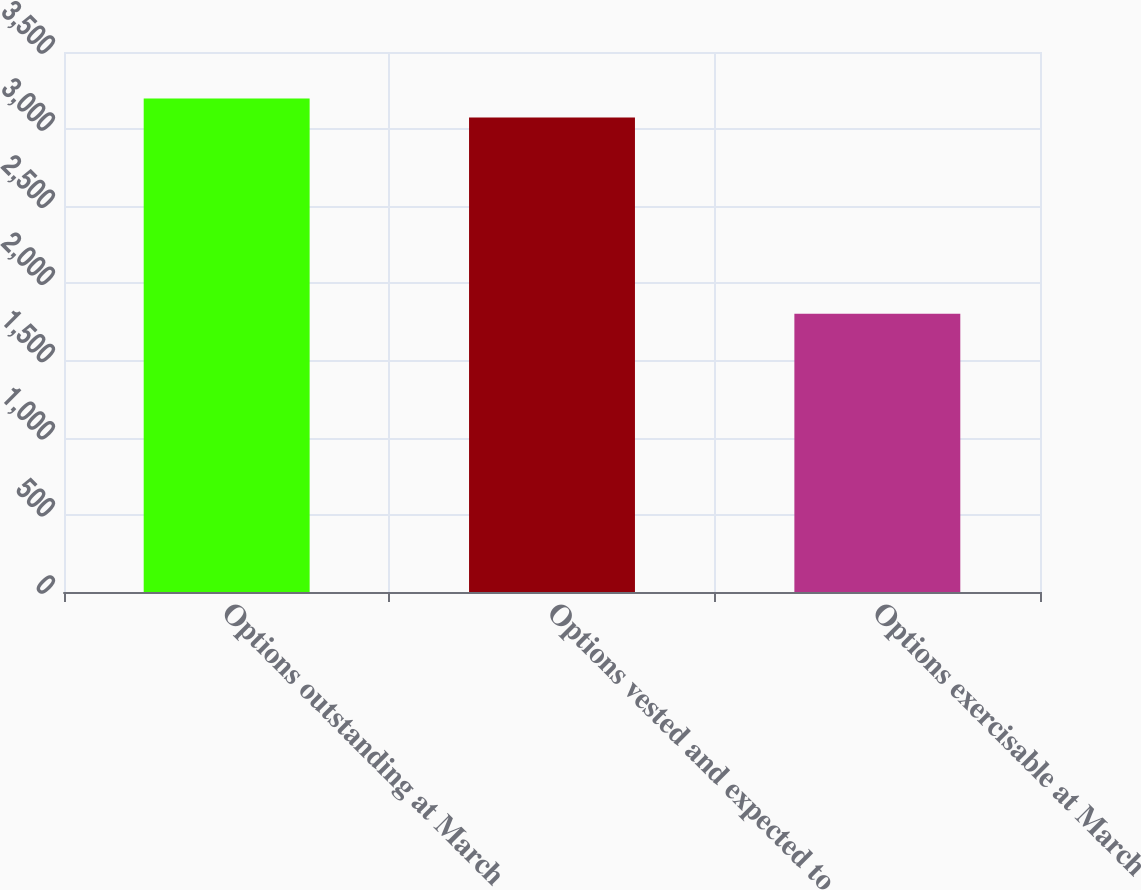<chart> <loc_0><loc_0><loc_500><loc_500><bar_chart><fcel>Options outstanding at March<fcel>Options vested and expected to<fcel>Options exercisable at March<nl><fcel>3198.4<fcel>3076.2<fcel>1804<nl></chart> 